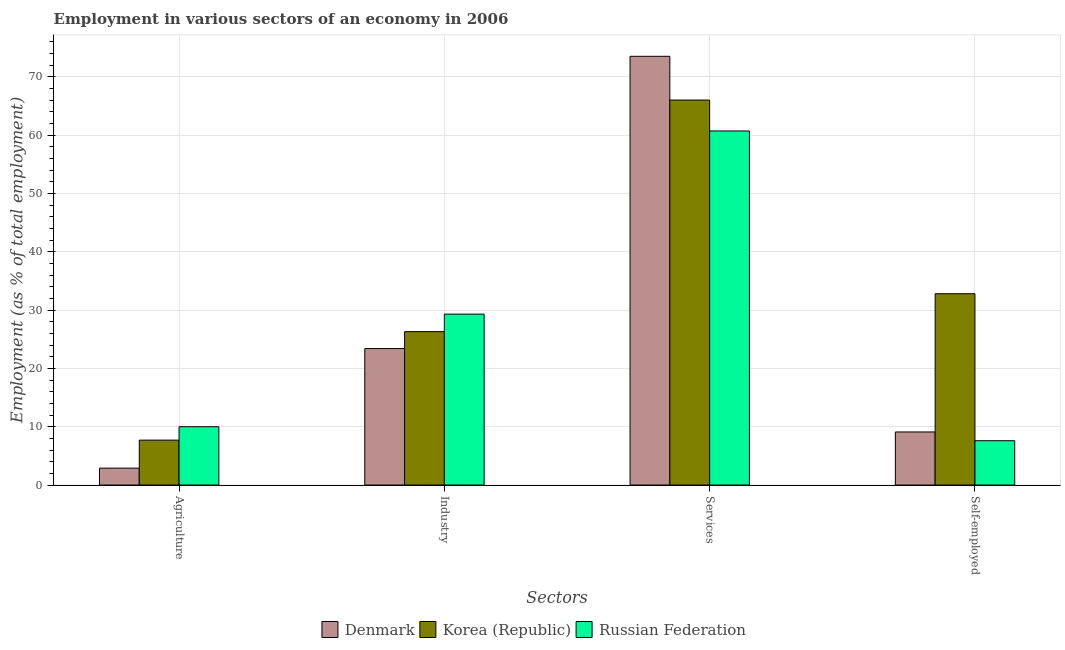How many different coloured bars are there?
Provide a succinct answer. 3. How many groups of bars are there?
Give a very brief answer. 4. How many bars are there on the 3rd tick from the left?
Make the answer very short. 3. How many bars are there on the 3rd tick from the right?
Ensure brevity in your answer.  3. What is the label of the 3rd group of bars from the left?
Make the answer very short. Services. What is the percentage of workers in industry in Korea (Republic)?
Provide a succinct answer. 26.3. Across all countries, what is the maximum percentage of self employed workers?
Offer a very short reply. 32.8. Across all countries, what is the minimum percentage of workers in industry?
Ensure brevity in your answer.  23.4. In which country was the percentage of workers in agriculture maximum?
Provide a succinct answer. Russian Federation. In which country was the percentage of self employed workers minimum?
Your answer should be very brief. Russian Federation. What is the total percentage of self employed workers in the graph?
Provide a short and direct response. 49.5. What is the difference between the percentage of workers in industry in Denmark and that in Korea (Republic)?
Give a very brief answer. -2.9. What is the difference between the percentage of self employed workers in Korea (Republic) and the percentage of workers in agriculture in Russian Federation?
Your answer should be compact. 22.8. What is the average percentage of workers in services per country?
Offer a terse response. 66.73. What is the difference between the percentage of workers in services and percentage of workers in agriculture in Russian Federation?
Keep it short and to the point. 50.7. In how many countries, is the percentage of workers in agriculture greater than 72 %?
Offer a terse response. 0. What is the ratio of the percentage of self employed workers in Russian Federation to that in Korea (Republic)?
Your answer should be very brief. 0.23. Is the percentage of workers in services in Korea (Republic) less than that in Denmark?
Ensure brevity in your answer.  Yes. What is the difference between the highest and the lowest percentage of workers in agriculture?
Offer a terse response. 7.1. In how many countries, is the percentage of workers in industry greater than the average percentage of workers in industry taken over all countries?
Offer a terse response. 1. Is the sum of the percentage of workers in services in Russian Federation and Korea (Republic) greater than the maximum percentage of workers in agriculture across all countries?
Keep it short and to the point. Yes. What does the 3rd bar from the left in Self-employed represents?
Give a very brief answer. Russian Federation. What does the 1st bar from the right in Agriculture represents?
Your response must be concise. Russian Federation. Is it the case that in every country, the sum of the percentage of workers in agriculture and percentage of workers in industry is greater than the percentage of workers in services?
Your answer should be compact. No. Are all the bars in the graph horizontal?
Ensure brevity in your answer.  No. How many countries are there in the graph?
Provide a short and direct response. 3. Does the graph contain any zero values?
Ensure brevity in your answer.  No. Where does the legend appear in the graph?
Make the answer very short. Bottom center. How many legend labels are there?
Offer a terse response. 3. What is the title of the graph?
Provide a succinct answer. Employment in various sectors of an economy in 2006. What is the label or title of the X-axis?
Your answer should be very brief. Sectors. What is the label or title of the Y-axis?
Your answer should be very brief. Employment (as % of total employment). What is the Employment (as % of total employment) in Denmark in Agriculture?
Your response must be concise. 2.9. What is the Employment (as % of total employment) of Korea (Republic) in Agriculture?
Provide a short and direct response. 7.7. What is the Employment (as % of total employment) of Russian Federation in Agriculture?
Provide a succinct answer. 10. What is the Employment (as % of total employment) of Denmark in Industry?
Your answer should be very brief. 23.4. What is the Employment (as % of total employment) of Korea (Republic) in Industry?
Provide a short and direct response. 26.3. What is the Employment (as % of total employment) in Russian Federation in Industry?
Ensure brevity in your answer.  29.3. What is the Employment (as % of total employment) of Denmark in Services?
Your response must be concise. 73.5. What is the Employment (as % of total employment) of Korea (Republic) in Services?
Your answer should be compact. 66. What is the Employment (as % of total employment) of Russian Federation in Services?
Offer a very short reply. 60.7. What is the Employment (as % of total employment) of Denmark in Self-employed?
Keep it short and to the point. 9.1. What is the Employment (as % of total employment) in Korea (Republic) in Self-employed?
Provide a succinct answer. 32.8. What is the Employment (as % of total employment) in Russian Federation in Self-employed?
Provide a succinct answer. 7.6. Across all Sectors, what is the maximum Employment (as % of total employment) of Denmark?
Provide a short and direct response. 73.5. Across all Sectors, what is the maximum Employment (as % of total employment) in Russian Federation?
Provide a short and direct response. 60.7. Across all Sectors, what is the minimum Employment (as % of total employment) of Denmark?
Provide a succinct answer. 2.9. Across all Sectors, what is the minimum Employment (as % of total employment) in Korea (Republic)?
Offer a very short reply. 7.7. Across all Sectors, what is the minimum Employment (as % of total employment) in Russian Federation?
Your answer should be very brief. 7.6. What is the total Employment (as % of total employment) of Denmark in the graph?
Offer a terse response. 108.9. What is the total Employment (as % of total employment) in Korea (Republic) in the graph?
Offer a terse response. 132.8. What is the total Employment (as % of total employment) in Russian Federation in the graph?
Ensure brevity in your answer.  107.6. What is the difference between the Employment (as % of total employment) of Denmark in Agriculture and that in Industry?
Ensure brevity in your answer.  -20.5. What is the difference between the Employment (as % of total employment) in Korea (Republic) in Agriculture and that in Industry?
Ensure brevity in your answer.  -18.6. What is the difference between the Employment (as % of total employment) in Russian Federation in Agriculture and that in Industry?
Provide a succinct answer. -19.3. What is the difference between the Employment (as % of total employment) in Denmark in Agriculture and that in Services?
Your answer should be compact. -70.6. What is the difference between the Employment (as % of total employment) in Korea (Republic) in Agriculture and that in Services?
Ensure brevity in your answer.  -58.3. What is the difference between the Employment (as % of total employment) of Russian Federation in Agriculture and that in Services?
Your answer should be compact. -50.7. What is the difference between the Employment (as % of total employment) of Korea (Republic) in Agriculture and that in Self-employed?
Ensure brevity in your answer.  -25.1. What is the difference between the Employment (as % of total employment) of Russian Federation in Agriculture and that in Self-employed?
Give a very brief answer. 2.4. What is the difference between the Employment (as % of total employment) of Denmark in Industry and that in Services?
Offer a very short reply. -50.1. What is the difference between the Employment (as % of total employment) in Korea (Republic) in Industry and that in Services?
Ensure brevity in your answer.  -39.7. What is the difference between the Employment (as % of total employment) of Russian Federation in Industry and that in Services?
Your answer should be very brief. -31.4. What is the difference between the Employment (as % of total employment) in Denmark in Industry and that in Self-employed?
Provide a short and direct response. 14.3. What is the difference between the Employment (as % of total employment) of Korea (Republic) in Industry and that in Self-employed?
Provide a succinct answer. -6.5. What is the difference between the Employment (as % of total employment) in Russian Federation in Industry and that in Self-employed?
Offer a very short reply. 21.7. What is the difference between the Employment (as % of total employment) in Denmark in Services and that in Self-employed?
Offer a terse response. 64.4. What is the difference between the Employment (as % of total employment) in Korea (Republic) in Services and that in Self-employed?
Keep it short and to the point. 33.2. What is the difference between the Employment (as % of total employment) in Russian Federation in Services and that in Self-employed?
Make the answer very short. 53.1. What is the difference between the Employment (as % of total employment) of Denmark in Agriculture and the Employment (as % of total employment) of Korea (Republic) in Industry?
Keep it short and to the point. -23.4. What is the difference between the Employment (as % of total employment) of Denmark in Agriculture and the Employment (as % of total employment) of Russian Federation in Industry?
Your response must be concise. -26.4. What is the difference between the Employment (as % of total employment) in Korea (Republic) in Agriculture and the Employment (as % of total employment) in Russian Federation in Industry?
Give a very brief answer. -21.6. What is the difference between the Employment (as % of total employment) of Denmark in Agriculture and the Employment (as % of total employment) of Korea (Republic) in Services?
Keep it short and to the point. -63.1. What is the difference between the Employment (as % of total employment) of Denmark in Agriculture and the Employment (as % of total employment) of Russian Federation in Services?
Keep it short and to the point. -57.8. What is the difference between the Employment (as % of total employment) of Korea (Republic) in Agriculture and the Employment (as % of total employment) of Russian Federation in Services?
Offer a very short reply. -53. What is the difference between the Employment (as % of total employment) in Denmark in Agriculture and the Employment (as % of total employment) in Korea (Republic) in Self-employed?
Keep it short and to the point. -29.9. What is the difference between the Employment (as % of total employment) in Denmark in Agriculture and the Employment (as % of total employment) in Russian Federation in Self-employed?
Provide a succinct answer. -4.7. What is the difference between the Employment (as % of total employment) of Korea (Republic) in Agriculture and the Employment (as % of total employment) of Russian Federation in Self-employed?
Give a very brief answer. 0.1. What is the difference between the Employment (as % of total employment) in Denmark in Industry and the Employment (as % of total employment) in Korea (Republic) in Services?
Make the answer very short. -42.6. What is the difference between the Employment (as % of total employment) in Denmark in Industry and the Employment (as % of total employment) in Russian Federation in Services?
Keep it short and to the point. -37.3. What is the difference between the Employment (as % of total employment) in Korea (Republic) in Industry and the Employment (as % of total employment) in Russian Federation in Services?
Ensure brevity in your answer.  -34.4. What is the difference between the Employment (as % of total employment) of Denmark in Services and the Employment (as % of total employment) of Korea (Republic) in Self-employed?
Your answer should be very brief. 40.7. What is the difference between the Employment (as % of total employment) of Denmark in Services and the Employment (as % of total employment) of Russian Federation in Self-employed?
Keep it short and to the point. 65.9. What is the difference between the Employment (as % of total employment) of Korea (Republic) in Services and the Employment (as % of total employment) of Russian Federation in Self-employed?
Ensure brevity in your answer.  58.4. What is the average Employment (as % of total employment) in Denmark per Sectors?
Give a very brief answer. 27.23. What is the average Employment (as % of total employment) of Korea (Republic) per Sectors?
Your answer should be compact. 33.2. What is the average Employment (as % of total employment) of Russian Federation per Sectors?
Make the answer very short. 26.9. What is the difference between the Employment (as % of total employment) in Denmark and Employment (as % of total employment) in Korea (Republic) in Agriculture?
Make the answer very short. -4.8. What is the difference between the Employment (as % of total employment) of Korea (Republic) and Employment (as % of total employment) of Russian Federation in Agriculture?
Provide a succinct answer. -2.3. What is the difference between the Employment (as % of total employment) in Korea (Republic) and Employment (as % of total employment) in Russian Federation in Industry?
Your answer should be compact. -3. What is the difference between the Employment (as % of total employment) in Denmark and Employment (as % of total employment) in Korea (Republic) in Services?
Offer a very short reply. 7.5. What is the difference between the Employment (as % of total employment) of Denmark and Employment (as % of total employment) of Russian Federation in Services?
Ensure brevity in your answer.  12.8. What is the difference between the Employment (as % of total employment) in Korea (Republic) and Employment (as % of total employment) in Russian Federation in Services?
Your answer should be very brief. 5.3. What is the difference between the Employment (as % of total employment) in Denmark and Employment (as % of total employment) in Korea (Republic) in Self-employed?
Make the answer very short. -23.7. What is the difference between the Employment (as % of total employment) of Korea (Republic) and Employment (as % of total employment) of Russian Federation in Self-employed?
Offer a terse response. 25.2. What is the ratio of the Employment (as % of total employment) of Denmark in Agriculture to that in Industry?
Provide a succinct answer. 0.12. What is the ratio of the Employment (as % of total employment) of Korea (Republic) in Agriculture to that in Industry?
Your answer should be very brief. 0.29. What is the ratio of the Employment (as % of total employment) of Russian Federation in Agriculture to that in Industry?
Your answer should be very brief. 0.34. What is the ratio of the Employment (as % of total employment) of Denmark in Agriculture to that in Services?
Your answer should be compact. 0.04. What is the ratio of the Employment (as % of total employment) of Korea (Republic) in Agriculture to that in Services?
Your answer should be very brief. 0.12. What is the ratio of the Employment (as % of total employment) in Russian Federation in Agriculture to that in Services?
Your answer should be compact. 0.16. What is the ratio of the Employment (as % of total employment) in Denmark in Agriculture to that in Self-employed?
Provide a short and direct response. 0.32. What is the ratio of the Employment (as % of total employment) in Korea (Republic) in Agriculture to that in Self-employed?
Make the answer very short. 0.23. What is the ratio of the Employment (as % of total employment) in Russian Federation in Agriculture to that in Self-employed?
Offer a terse response. 1.32. What is the ratio of the Employment (as % of total employment) in Denmark in Industry to that in Services?
Ensure brevity in your answer.  0.32. What is the ratio of the Employment (as % of total employment) of Korea (Republic) in Industry to that in Services?
Your response must be concise. 0.4. What is the ratio of the Employment (as % of total employment) of Russian Federation in Industry to that in Services?
Offer a terse response. 0.48. What is the ratio of the Employment (as % of total employment) of Denmark in Industry to that in Self-employed?
Give a very brief answer. 2.57. What is the ratio of the Employment (as % of total employment) in Korea (Republic) in Industry to that in Self-employed?
Provide a succinct answer. 0.8. What is the ratio of the Employment (as % of total employment) in Russian Federation in Industry to that in Self-employed?
Offer a very short reply. 3.86. What is the ratio of the Employment (as % of total employment) in Denmark in Services to that in Self-employed?
Your answer should be compact. 8.08. What is the ratio of the Employment (as % of total employment) of Korea (Republic) in Services to that in Self-employed?
Offer a very short reply. 2.01. What is the ratio of the Employment (as % of total employment) in Russian Federation in Services to that in Self-employed?
Provide a succinct answer. 7.99. What is the difference between the highest and the second highest Employment (as % of total employment) of Denmark?
Provide a short and direct response. 50.1. What is the difference between the highest and the second highest Employment (as % of total employment) of Korea (Republic)?
Offer a very short reply. 33.2. What is the difference between the highest and the second highest Employment (as % of total employment) of Russian Federation?
Keep it short and to the point. 31.4. What is the difference between the highest and the lowest Employment (as % of total employment) in Denmark?
Provide a short and direct response. 70.6. What is the difference between the highest and the lowest Employment (as % of total employment) of Korea (Republic)?
Your answer should be compact. 58.3. What is the difference between the highest and the lowest Employment (as % of total employment) of Russian Federation?
Your answer should be very brief. 53.1. 